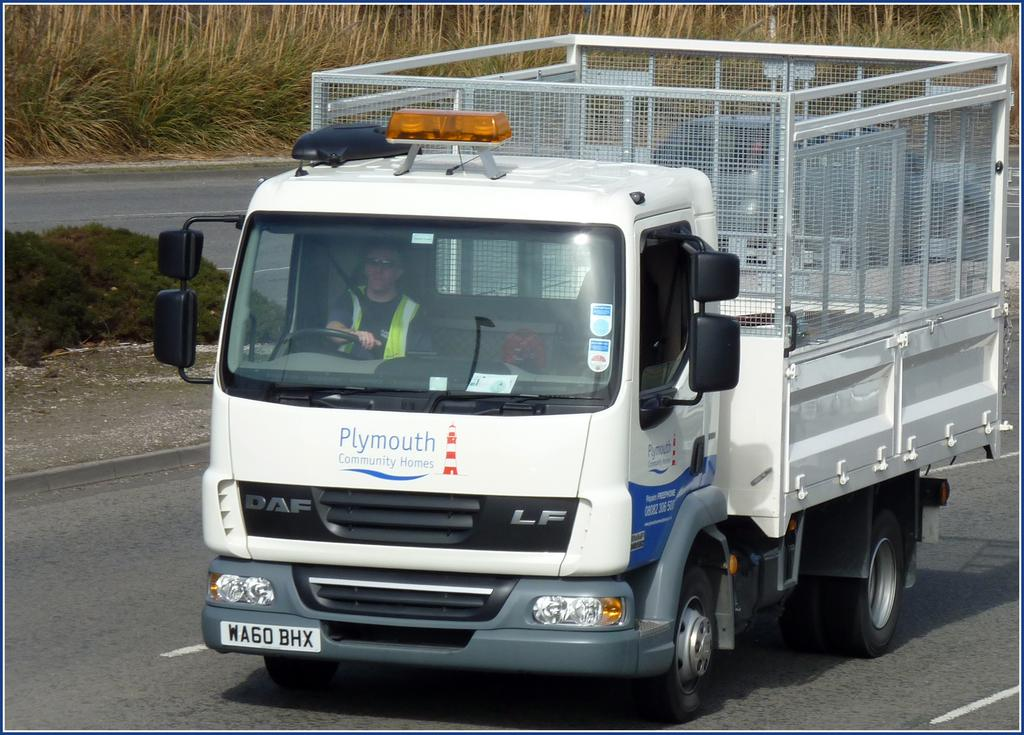What is the person in the image doing? The person is driving a vehicle in the image. Where is the vehicle located? The vehicle is on a road. What can be seen in the background of the image? There is grass visible in the background of the image. How does the pencil help the person drive the vehicle in the image? There is no pencil present in the image, and therefore it cannot help the person drive the vehicle. 